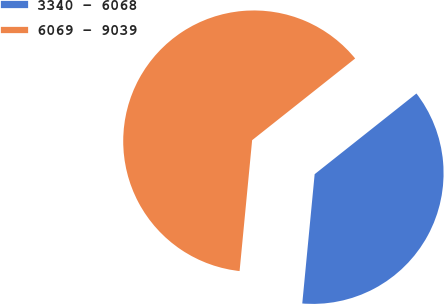Convert chart to OTSL. <chart><loc_0><loc_0><loc_500><loc_500><pie_chart><fcel>3340 - 6068<fcel>6069 - 9039<nl><fcel>37.19%<fcel>62.81%<nl></chart> 